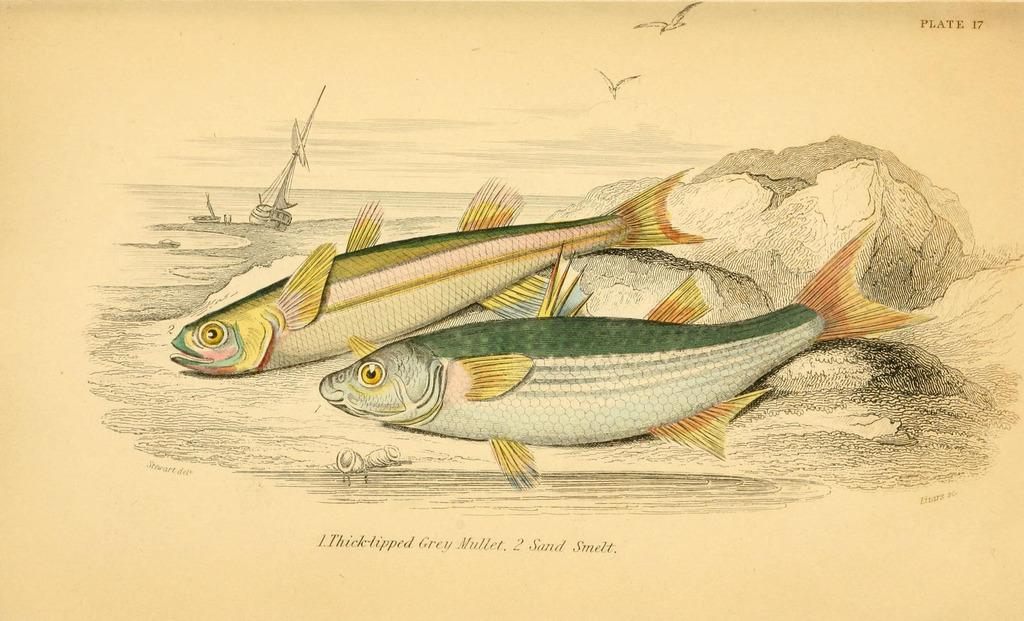What animals can be seen in the image? There are two fishes in the image. What is the primary element in which the fishes are situated? There is water in the image. What other objects or creatures can be seen in the image? There are boats and birds in the image. How is the image presented? All of these elements are depicted on a paper. What type of muscle is being exercised by the fishes in the image? There is no indication in the image that the fishes are exercising any muscles, as they are simply depicted in water. 